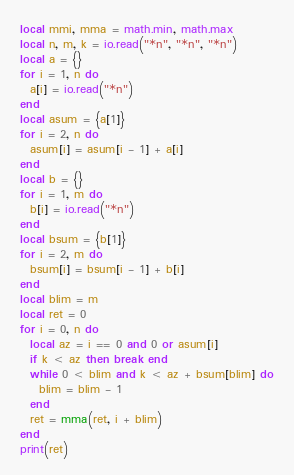Convert code to text. <code><loc_0><loc_0><loc_500><loc_500><_Lua_>local mmi, mma = math.min, math.max
local n, m, k = io.read("*n", "*n", "*n")
local a = {}
for i = 1, n do
  a[i] = io.read("*n")
end
local asum = {a[1]}
for i = 2, n do
  asum[i] = asum[i - 1] + a[i]
end
local b = {}
for i = 1, m do
  b[i] = io.read("*n")
end
local bsum = {b[1]}
for i = 2, m do
  bsum[i] = bsum[i - 1] + b[i]
end
local blim = m
local ret = 0
for i = 0, n do
  local az = i == 0 and 0 or asum[i]
  if k < az then break end
  while 0 < blim and k < az + bsum[blim] do
    blim = blim - 1
  end
  ret = mma(ret, i + blim)
end
print(ret)
</code> 